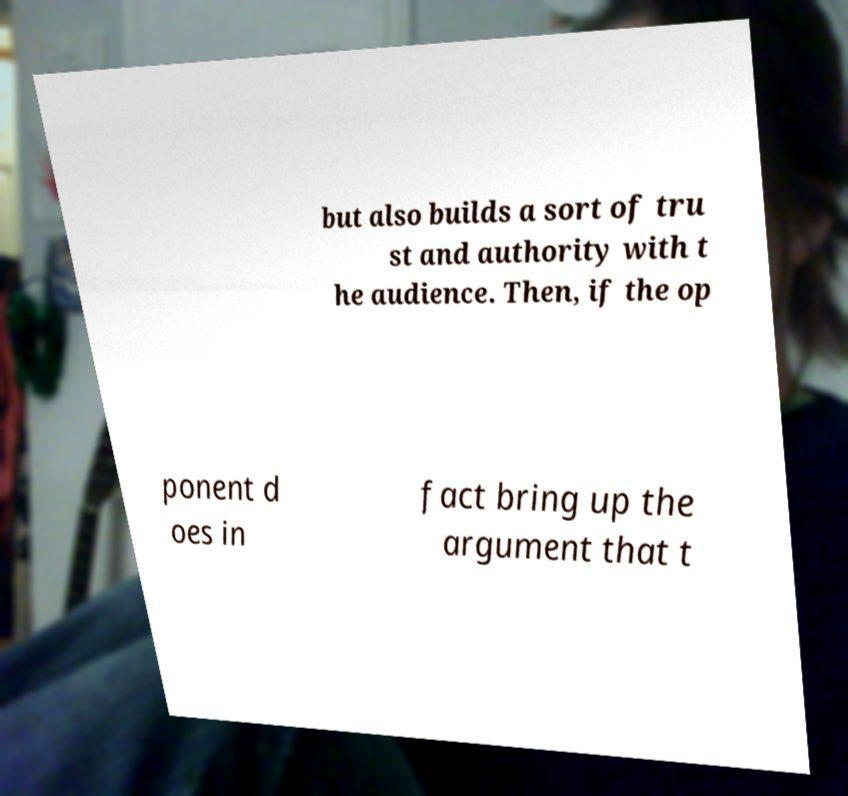I need the written content from this picture converted into text. Can you do that? but also builds a sort of tru st and authority with t he audience. Then, if the op ponent d oes in fact bring up the argument that t 